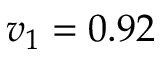Convert formula to latex. <formula><loc_0><loc_0><loc_500><loc_500>v _ { 1 } = 0 . 9 2</formula> 